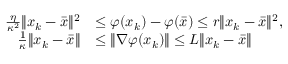<formula> <loc_0><loc_0><loc_500><loc_500>\begin{array} { r l } { \frac { \eta } { \kappa ^ { 2 } } \| x _ { k } - \bar { x } \| ^ { 2 } } & { \leq \varphi ( x _ { k } ) - \varphi ( \bar { x } ) \leq r \| x _ { k } - \bar { x } \| ^ { 2 } , } \\ { \quad \frac { 1 } { \kappa } \| x _ { k } - \bar { x } \| } & { \leq \| \nabla \varphi ( x _ { k } ) \| \leq L \| x _ { k } - \bar { x } \| } \end{array}</formula> 